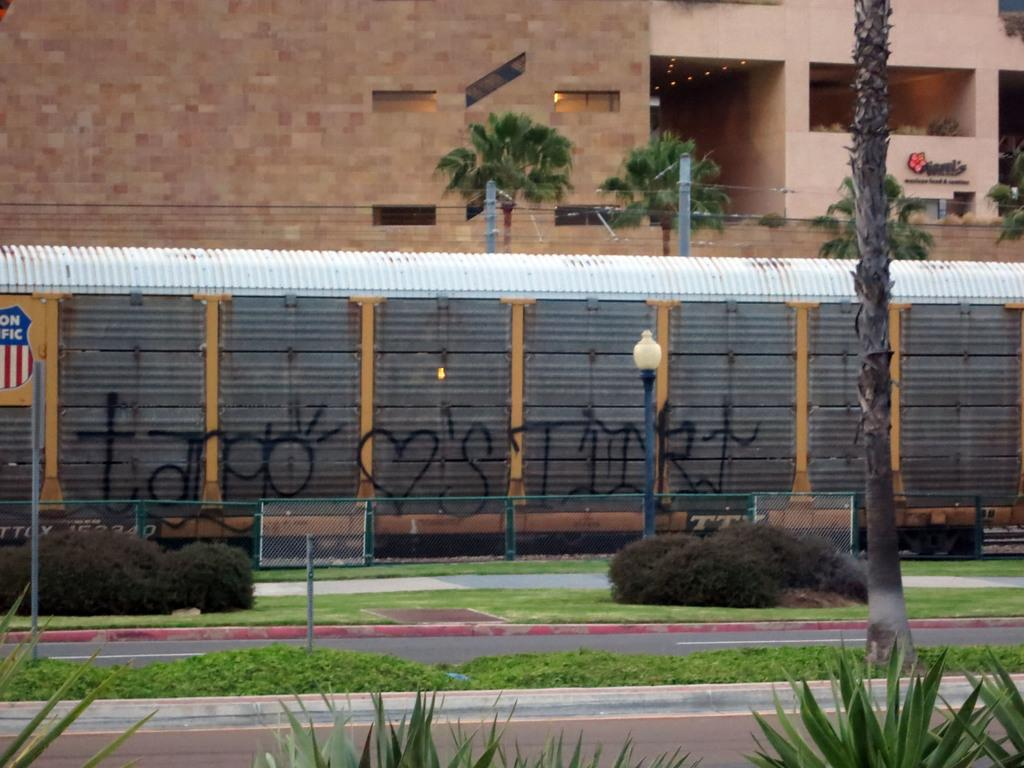What is the main subject of the image? The main subject of the image is a train. What is the train doing in the image? The train is passing on tracks in the image. What can be seen behind the train? There is a huge building and trees behind the train. What type of vegetation is present on the left side of the image? There are bushes and grass on the left side of the image. What else is visible in the image besides the train and vegetation? There is a road in the image. What type of attraction can be seen in the image? There is no attraction present in the image; it features a train passing on tracks with a background of a huge building, trees, and a road. What is the train's reaction to the box in the image? There is no box present in the image, so the train's reaction to a box cannot be determined. 